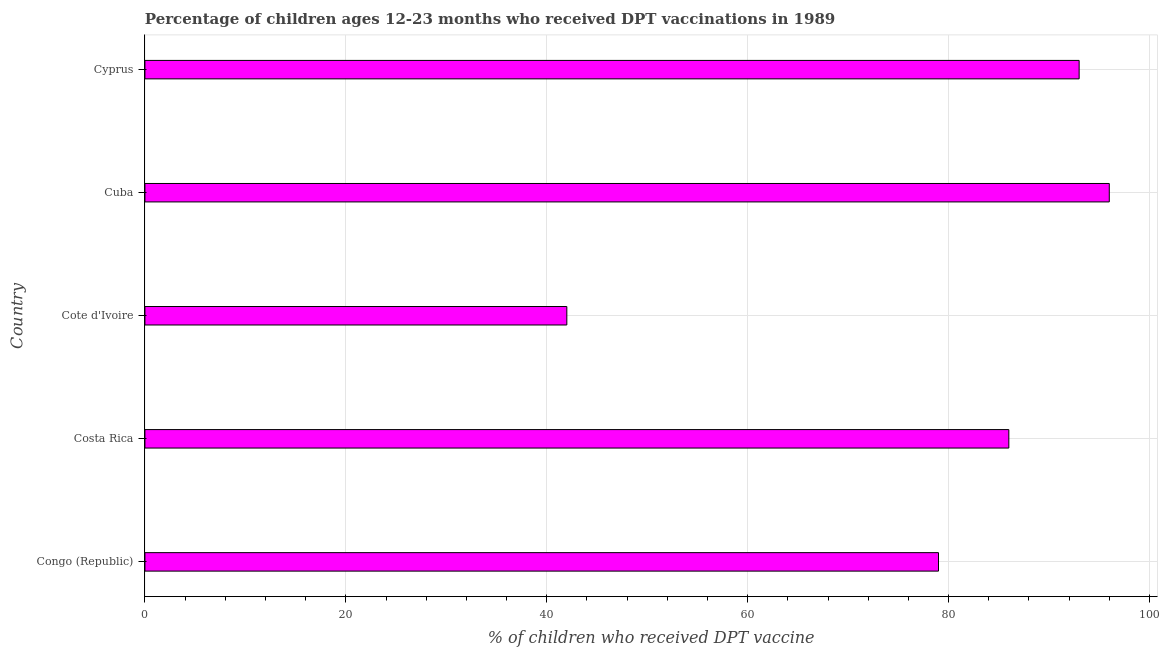Does the graph contain any zero values?
Your answer should be compact. No. Does the graph contain grids?
Offer a terse response. Yes. What is the title of the graph?
Give a very brief answer. Percentage of children ages 12-23 months who received DPT vaccinations in 1989. What is the label or title of the X-axis?
Provide a succinct answer. % of children who received DPT vaccine. What is the percentage of children who received dpt vaccine in Cuba?
Your response must be concise. 96. Across all countries, what is the maximum percentage of children who received dpt vaccine?
Give a very brief answer. 96. Across all countries, what is the minimum percentage of children who received dpt vaccine?
Provide a succinct answer. 42. In which country was the percentage of children who received dpt vaccine maximum?
Keep it short and to the point. Cuba. In which country was the percentage of children who received dpt vaccine minimum?
Make the answer very short. Cote d'Ivoire. What is the sum of the percentage of children who received dpt vaccine?
Offer a terse response. 396. What is the average percentage of children who received dpt vaccine per country?
Ensure brevity in your answer.  79.2. What is the median percentage of children who received dpt vaccine?
Your answer should be very brief. 86. What is the ratio of the percentage of children who received dpt vaccine in Cuba to that in Cyprus?
Provide a succinct answer. 1.03. Is the difference between the percentage of children who received dpt vaccine in Congo (Republic) and Cuba greater than the difference between any two countries?
Offer a terse response. No. Is the sum of the percentage of children who received dpt vaccine in Costa Rica and Cuba greater than the maximum percentage of children who received dpt vaccine across all countries?
Keep it short and to the point. Yes. How many bars are there?
Your response must be concise. 5. What is the difference between two consecutive major ticks on the X-axis?
Give a very brief answer. 20. Are the values on the major ticks of X-axis written in scientific E-notation?
Provide a short and direct response. No. What is the % of children who received DPT vaccine in Congo (Republic)?
Your answer should be very brief. 79. What is the % of children who received DPT vaccine of Cuba?
Give a very brief answer. 96. What is the % of children who received DPT vaccine of Cyprus?
Your answer should be very brief. 93. What is the difference between the % of children who received DPT vaccine in Congo (Republic) and Costa Rica?
Your answer should be very brief. -7. What is the difference between the % of children who received DPT vaccine in Congo (Republic) and Cuba?
Keep it short and to the point. -17. What is the difference between the % of children who received DPT vaccine in Congo (Republic) and Cyprus?
Keep it short and to the point. -14. What is the difference between the % of children who received DPT vaccine in Costa Rica and Cote d'Ivoire?
Offer a terse response. 44. What is the difference between the % of children who received DPT vaccine in Cote d'Ivoire and Cuba?
Your answer should be very brief. -54. What is the difference between the % of children who received DPT vaccine in Cote d'Ivoire and Cyprus?
Offer a terse response. -51. What is the difference between the % of children who received DPT vaccine in Cuba and Cyprus?
Give a very brief answer. 3. What is the ratio of the % of children who received DPT vaccine in Congo (Republic) to that in Costa Rica?
Your answer should be very brief. 0.92. What is the ratio of the % of children who received DPT vaccine in Congo (Republic) to that in Cote d'Ivoire?
Offer a terse response. 1.88. What is the ratio of the % of children who received DPT vaccine in Congo (Republic) to that in Cuba?
Ensure brevity in your answer.  0.82. What is the ratio of the % of children who received DPT vaccine in Congo (Republic) to that in Cyprus?
Provide a succinct answer. 0.85. What is the ratio of the % of children who received DPT vaccine in Costa Rica to that in Cote d'Ivoire?
Your response must be concise. 2.05. What is the ratio of the % of children who received DPT vaccine in Costa Rica to that in Cuba?
Make the answer very short. 0.9. What is the ratio of the % of children who received DPT vaccine in Costa Rica to that in Cyprus?
Provide a short and direct response. 0.93. What is the ratio of the % of children who received DPT vaccine in Cote d'Ivoire to that in Cuba?
Offer a terse response. 0.44. What is the ratio of the % of children who received DPT vaccine in Cote d'Ivoire to that in Cyprus?
Your answer should be very brief. 0.45. What is the ratio of the % of children who received DPT vaccine in Cuba to that in Cyprus?
Provide a succinct answer. 1.03. 